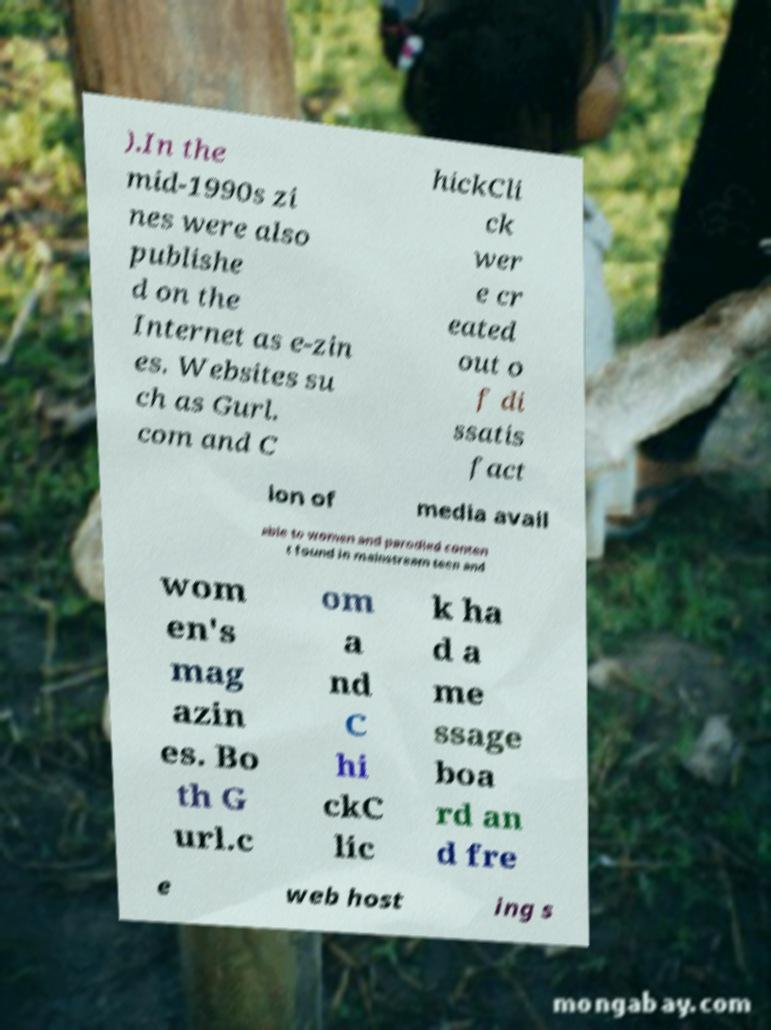Please read and relay the text visible in this image. What does it say? ).In the mid-1990s zi nes were also publishe d on the Internet as e-zin es. Websites su ch as Gurl. com and C hickCli ck wer e cr eated out o f di ssatis fact ion of media avail able to women and parodied conten t found in mainstream teen and wom en's mag azin es. Bo th G url.c om a nd C hi ckC lic k ha d a me ssage boa rd an d fre e web host ing s 